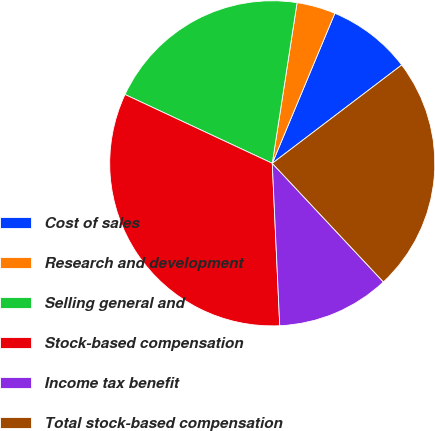Convert chart to OTSL. <chart><loc_0><loc_0><loc_500><loc_500><pie_chart><fcel>Cost of sales<fcel>Research and development<fcel>Selling general and<fcel>Stock-based compensation<fcel>Income tax benefit<fcel>Total stock-based compensation<nl><fcel>8.37%<fcel>3.85%<fcel>20.48%<fcel>32.69%<fcel>11.25%<fcel>23.36%<nl></chart> 